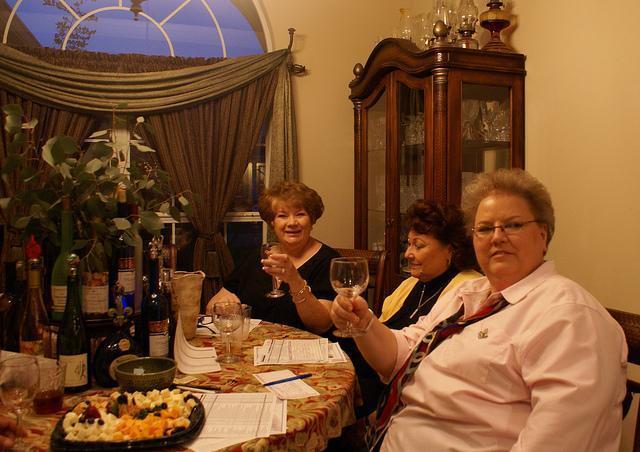How many people are in the picture?
Give a very brief answer. 3. How many bottles can be seen?
Give a very brief answer. 6. 